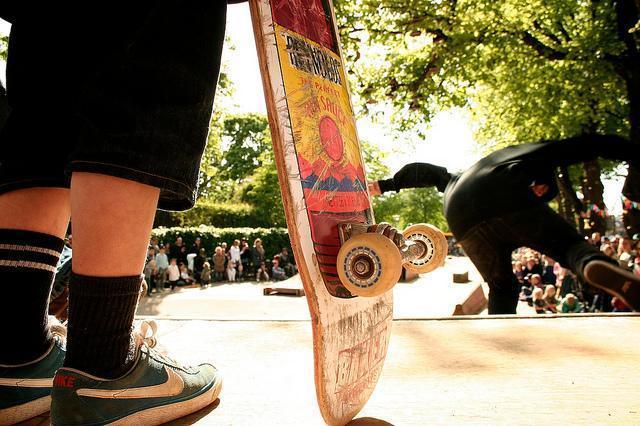How many skateboards are there?
Give a very brief answer. 1. How many people are there?
Give a very brief answer. 3. How many blue train cars are there?
Give a very brief answer. 0. 